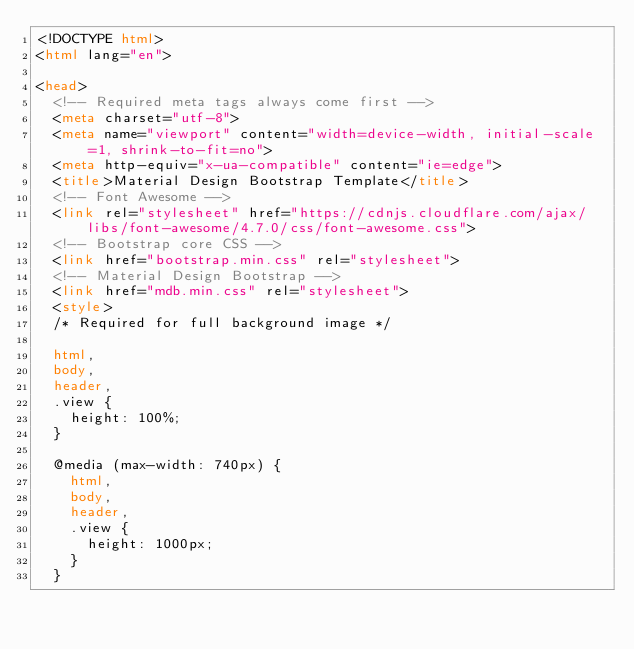<code> <loc_0><loc_0><loc_500><loc_500><_HTML_><!DOCTYPE html>
<html lang="en">

<head>
  <!-- Required meta tags always come first -->
  <meta charset="utf-8">
  <meta name="viewport" content="width=device-width, initial-scale=1, shrink-to-fit=no">
  <meta http-equiv="x-ua-compatible" content="ie=edge">
  <title>Material Design Bootstrap Template</title>
  <!-- Font Awesome -->
  <link rel="stylesheet" href="https://cdnjs.cloudflare.com/ajax/libs/font-awesome/4.7.0/css/font-awesome.css">
  <!-- Bootstrap core CSS -->
  <link href="bootstrap.min.css" rel="stylesheet">
  <!-- Material Design Bootstrap -->
  <link href="mdb.min.css" rel="stylesheet">
  <style>
  /* Required for full background image */

  html,
  body,
  header,
  .view {
    height: 100%;
  }

  @media (max-width: 740px) {
    html,
    body,
    header,
    .view {
      height: 1000px;
    }
  }</code> 